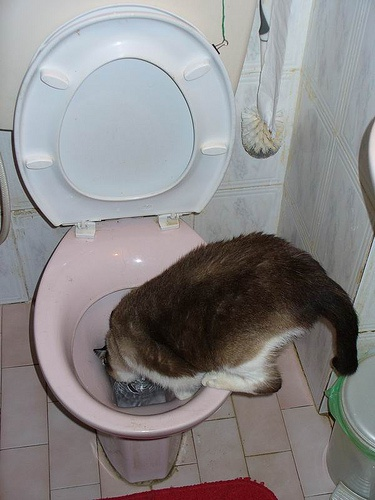Describe the objects in this image and their specific colors. I can see toilet in darkgray, black, and gray tones and cat in darkgray, black, and gray tones in this image. 